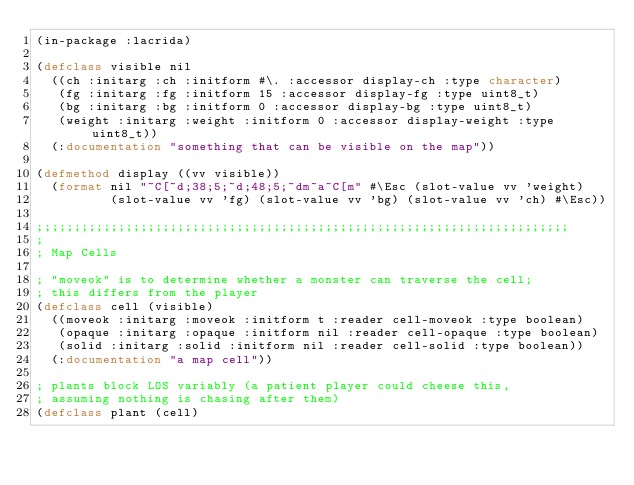<code> <loc_0><loc_0><loc_500><loc_500><_Lisp_>(in-package :lacrida)

(defclass visible nil
  ((ch :initarg :ch :initform #\. :accessor display-ch :type character)
   (fg :initarg :fg :initform 15 :accessor display-fg :type uint8_t)
   (bg :initarg :bg :initform 0 :accessor display-bg :type uint8_t)
   (weight :initarg :weight :initform 0 :accessor display-weight :type uint8_t))
  (:documentation "something that can be visible on the map"))

(defmethod display ((vv visible))
  (format nil "~C[~d;38;5;~d;48;5;~dm~a~C[m" #\Esc (slot-value vv 'weight)
          (slot-value vv 'fg) (slot-value vv 'bg) (slot-value vv 'ch) #\Esc))

;;;;;;;;;;;;;;;;;;;;;;;;;;;;;;;;;;;;;;;;;;;;;;;;;;;;;;;;;;;;;;;;;;;;;;;;
;
; Map Cells

; "moveok" is to determine whether a monster can traverse the cell;
; this differs from the player
(defclass cell (visible)
  ((moveok :initarg :moveok :initform t :reader cell-moveok :type boolean)
   (opaque :initarg :opaque :initform nil :reader cell-opaque :type boolean)
   (solid :initarg :solid :initform nil :reader cell-solid :type boolean))
  (:documentation "a map cell"))

; plants block LOS variably (a patient player could cheese this,
; assuming nothing is chasing after them)
(defclass plant (cell)</code> 